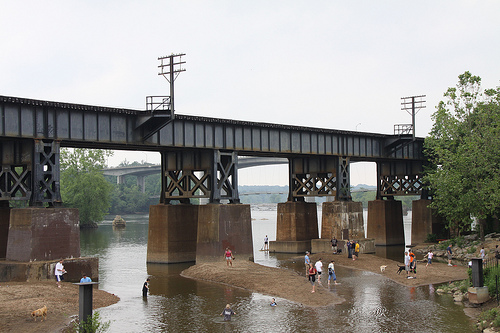<image>
Is the bridge above the river? Yes. The bridge is positioned above the river in the vertical space, higher up in the scene. 